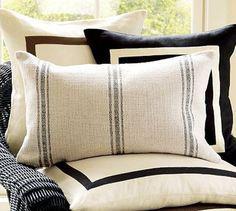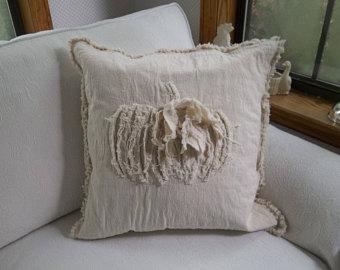The first image is the image on the left, the second image is the image on the right. For the images shown, is this caption "There are at least three pillows in one of the images." true? Answer yes or no. Yes. 